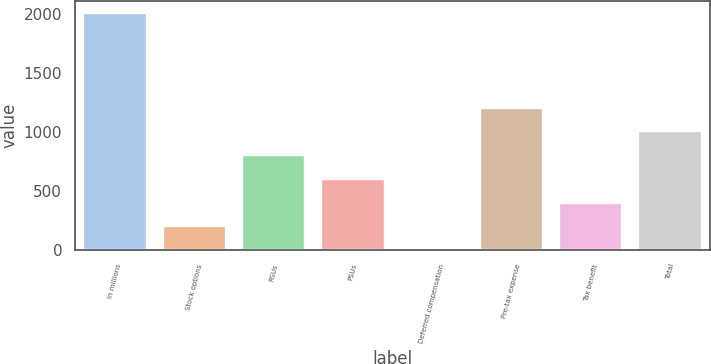Convert chart to OTSL. <chart><loc_0><loc_0><loc_500><loc_500><bar_chart><fcel>In millions<fcel>Stock options<fcel>RSUs<fcel>PSUs<fcel>Deferred compensation<fcel>Pre-tax expense<fcel>Tax benefit<fcel>Total<nl><fcel>2015<fcel>201.77<fcel>806.18<fcel>604.71<fcel>0.3<fcel>1209.12<fcel>403.24<fcel>1007.65<nl></chart> 